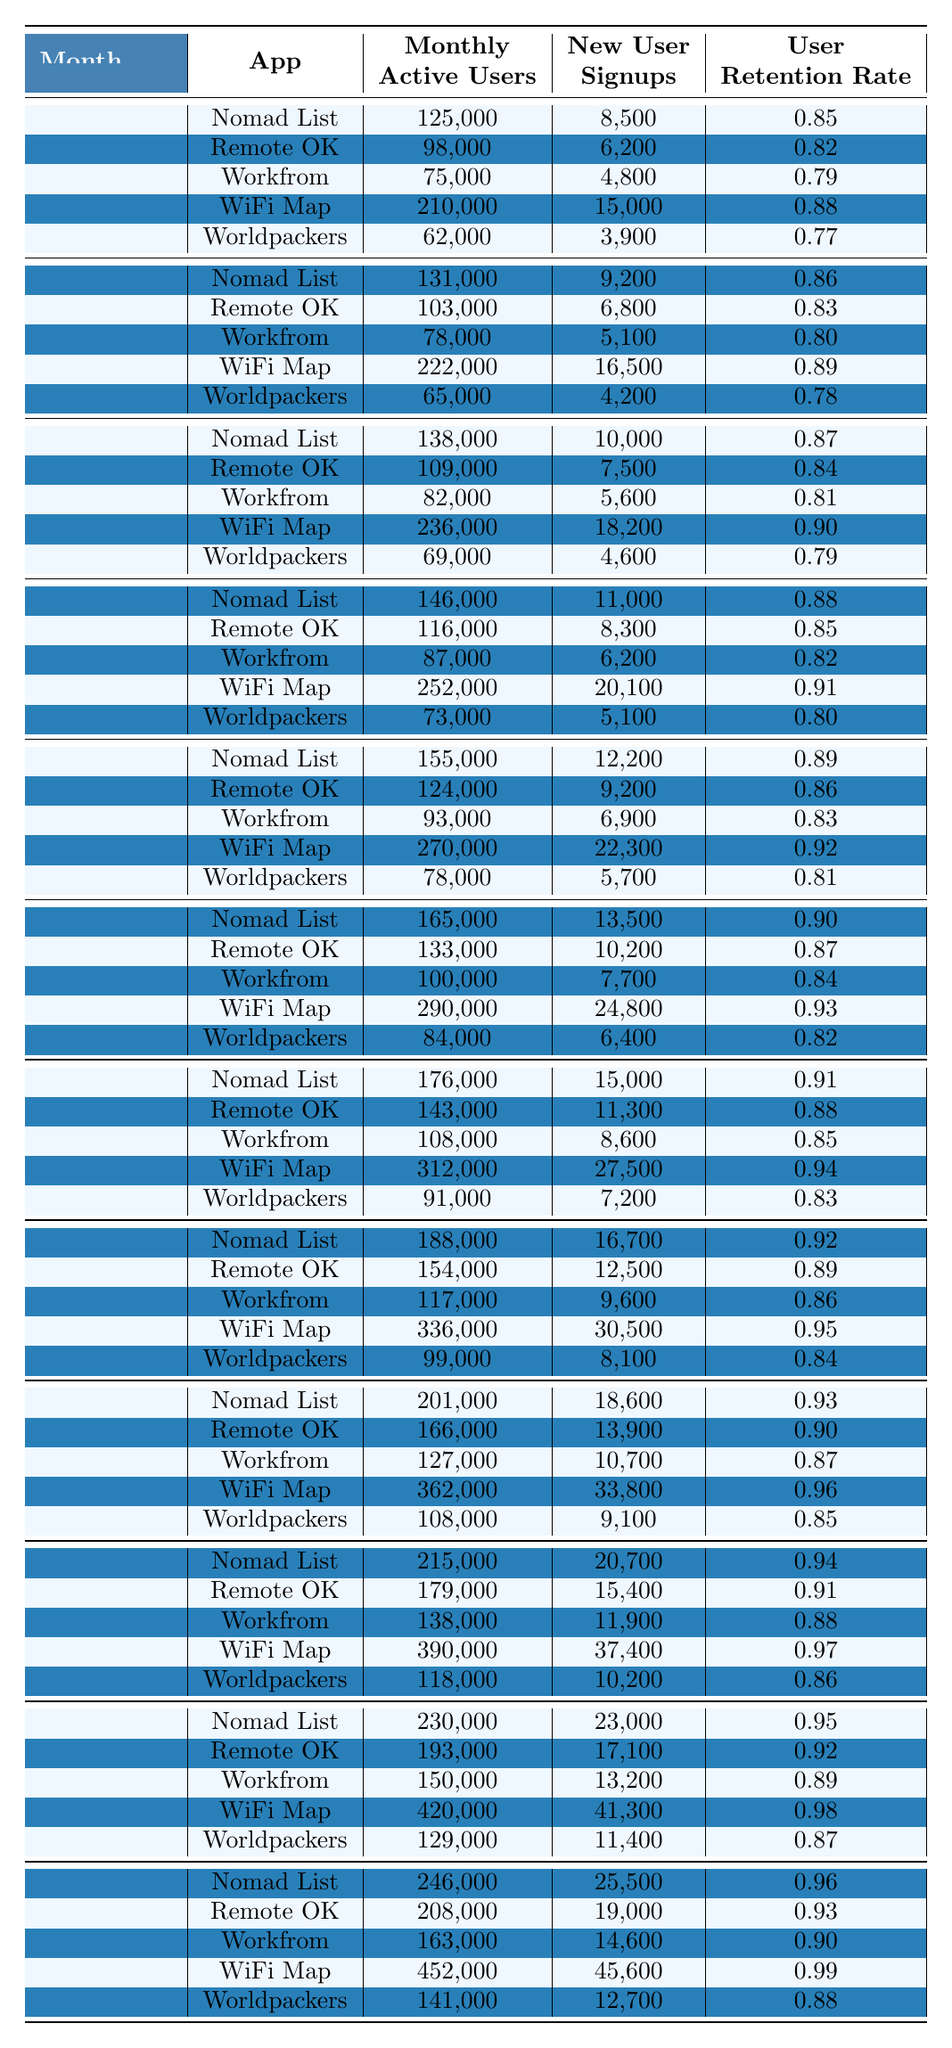What was the Monthly Active Users count for WiFi Map in December? In December, the table shows that WiFi Map had 452,000 Monthly Active Users recorded.
Answer: 452,000 Which app had the highest New User Signups in November? The table lists WiFi Map as having 41,300 New User Signups in November, which is the highest among all apps for that month.
Answer: WiFi Map What is the User Retention Rate for Workfrom in July? According to the table, Workfrom had a User Retention Rate of 0.85 in July.
Answer: 0.85 Which app had the lowest Monthly Active Users across all months? The table shows that Worldpackers had the lowest Monthly Active Users in January at 62,000.
Answer: Worldpackers What is the difference in Monthly Active Users between Nomad List in October and in January? For Nomad List, the Monthly Active Users in October is 215,000 and in January is 125,000. The difference is 215,000 - 125,000 = 90,000.
Answer: 90,000 Which app consistently maintained the highest Monthly Active Users over the months? By scanning the table, WiFi Map shows consistent growth each month, ending with 452,000 in December, the highest value across all months.
Answer: WiFi Map What was the average User Retention Rate for Remote OK over the 12 months? Summing the User Retention Rates (0.82, 0.83, 0.84, 0.85, 0.86, 0.87, 0.88, 0.89, 0.90, 0.91, 0.92, 0.93) gives 10.41, which when divided by 12 gives an average of 0.8684, rounded to 0.87.
Answer: 0.87 In which month did Worldpackers see the highest Monthly Active Users? The table indicates that Worldpackers had its peak Monthly Active Users in November with 129,000.
Answer: November What is the trend of New User Signups for WiFi Map from January to December? WiFi Map shows an increasing trend in New User Signups, from 15,000 in January to 45,600 in December.
Answer: Increasing Was the User Retention Rate for Workfrom ever greater than 0.90 in any month? Looking through the table, Workfrom’s highest User Retention Rate was 0.89 in November, indicating it never exceeded 0.90.
Answer: No 